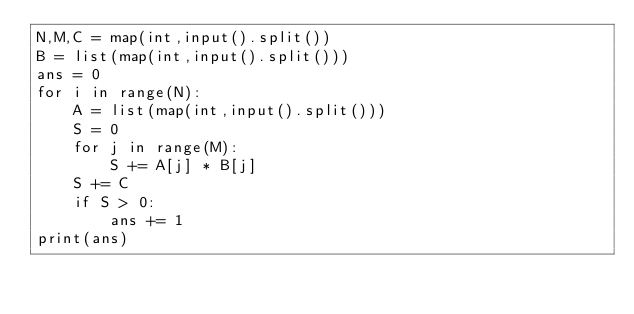<code> <loc_0><loc_0><loc_500><loc_500><_Python_>N,M,C = map(int,input().split())
B = list(map(int,input().split()))
ans = 0
for i in range(N):
    A = list(map(int,input().split()))
    S = 0
    for j in range(M):
        S += A[j] * B[j] 
    S += C
    if S > 0:
        ans += 1
print(ans)
</code> 